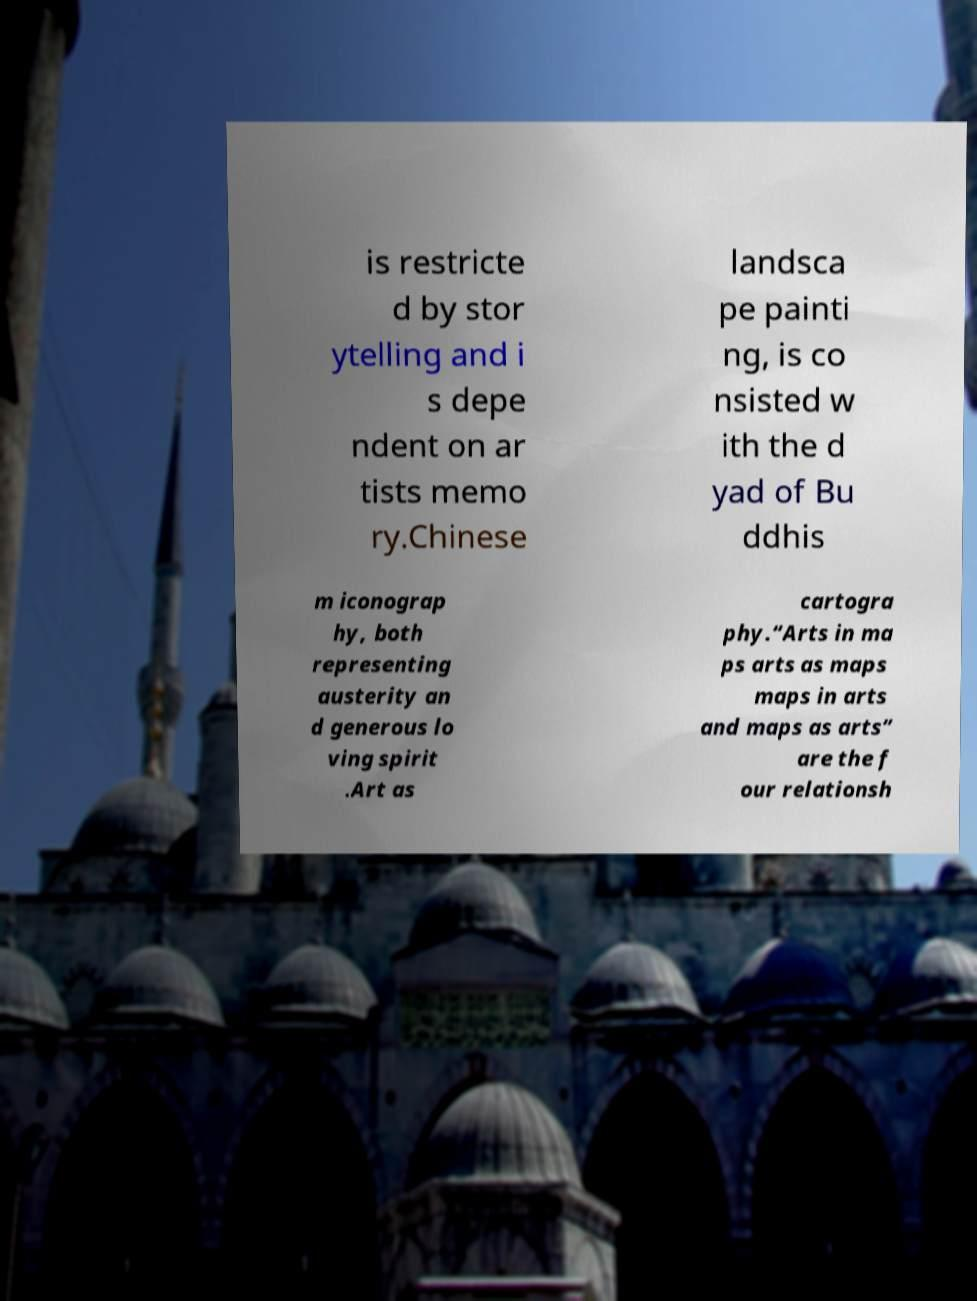Please identify and transcribe the text found in this image. is restricte d by stor ytelling and i s depe ndent on ar tists memo ry.Chinese landsca pe painti ng, is co nsisted w ith the d yad of Bu ddhis m iconograp hy, both representing austerity an d generous lo ving spirit .Art as cartogra phy.“Arts in ma ps arts as maps maps in arts and maps as arts” are the f our relationsh 